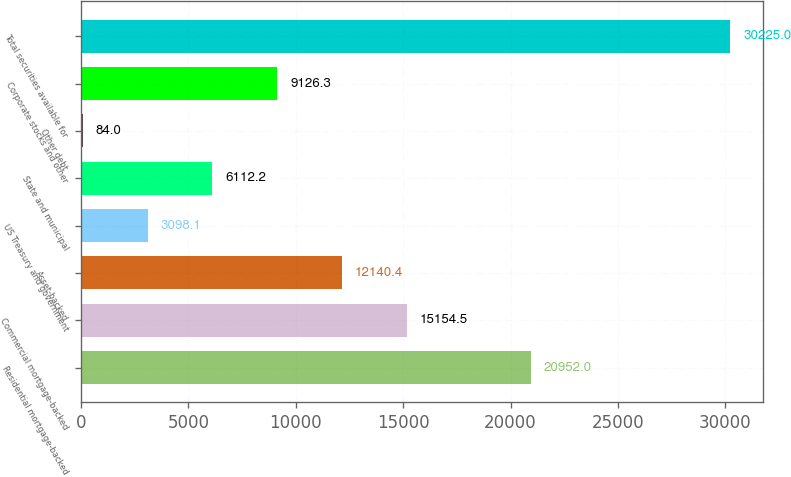<chart> <loc_0><loc_0><loc_500><loc_500><bar_chart><fcel>Residential mortgage-backed<fcel>Commercial mortgage-backed<fcel>Asset-backed<fcel>US Treasury and government<fcel>State and municipal<fcel>Other debt<fcel>Corporate stocks and other<fcel>Total securities available for<nl><fcel>20952<fcel>15154.5<fcel>12140.4<fcel>3098.1<fcel>6112.2<fcel>84<fcel>9126.3<fcel>30225<nl></chart> 